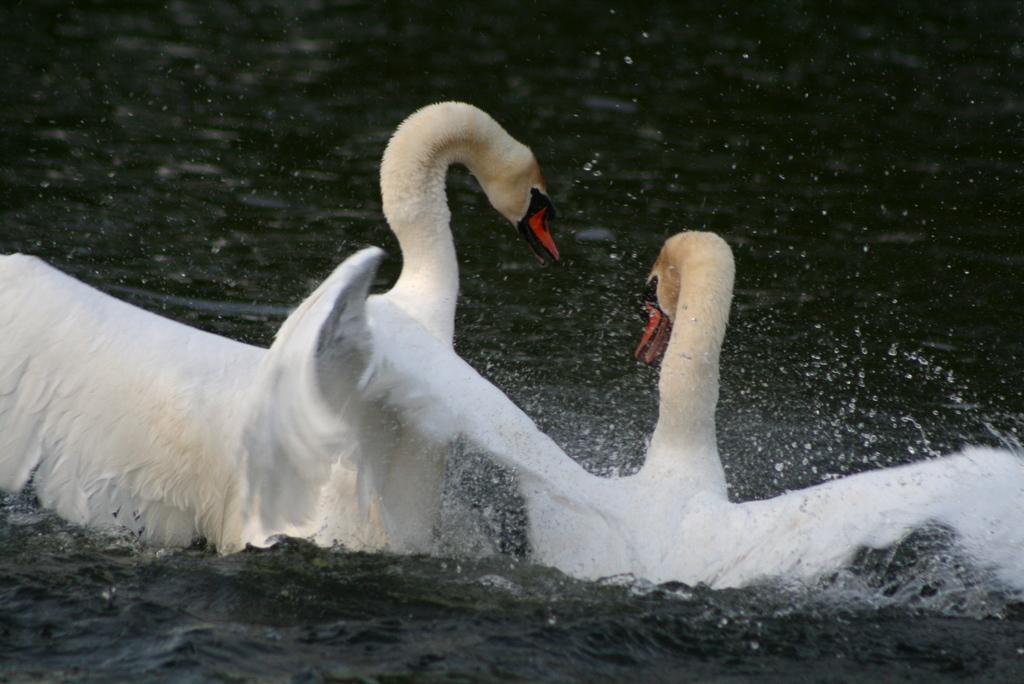In one or two sentences, can you explain what this image depicts? This image consists of swans in white color. At the bottom, there is water. 